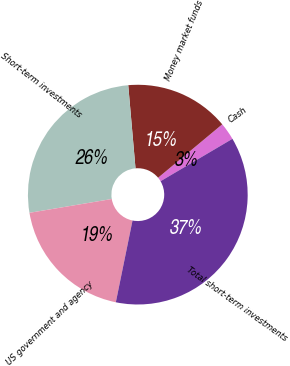Convert chart to OTSL. <chart><loc_0><loc_0><loc_500><loc_500><pie_chart><fcel>Cash<fcel>Money market funds<fcel>Short-term investments<fcel>US government and agency<fcel>Total short-term investments<nl><fcel>2.57%<fcel>15.34%<fcel>26.26%<fcel>19.15%<fcel>36.69%<nl></chart> 